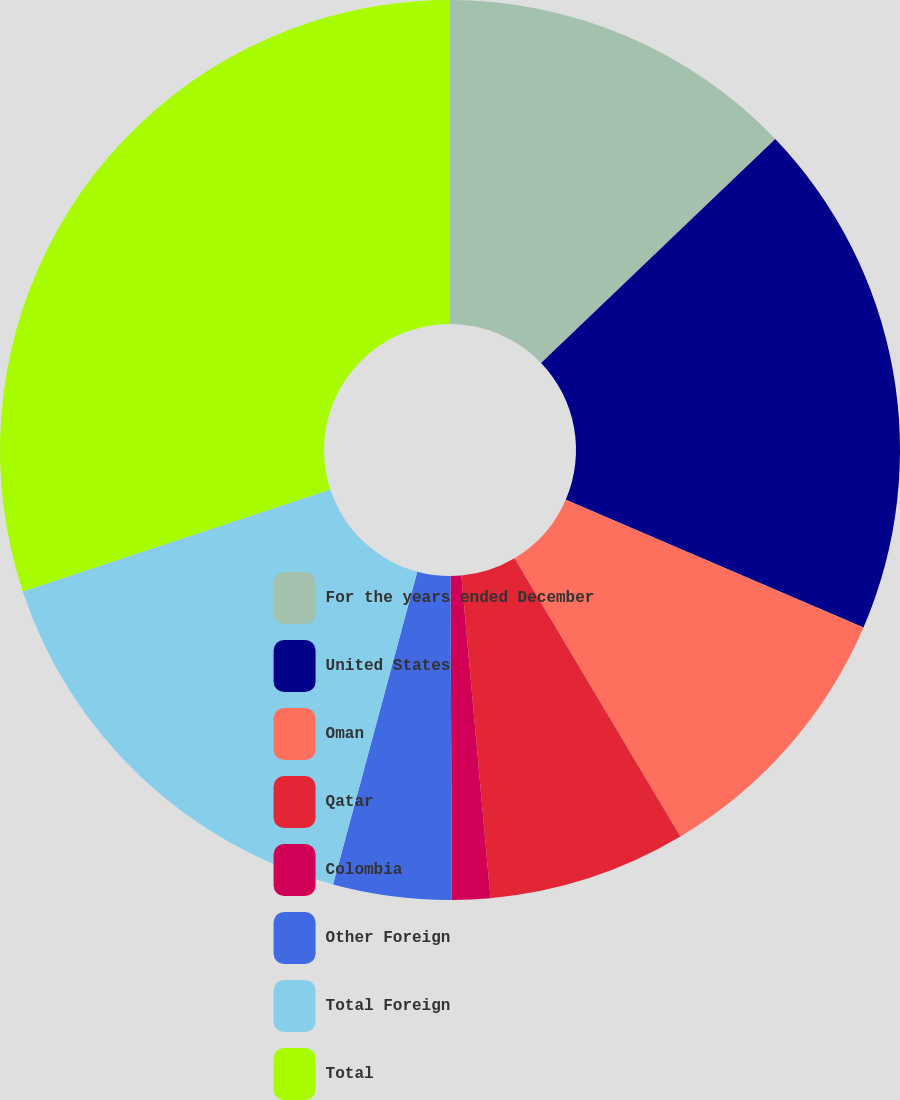<chart> <loc_0><loc_0><loc_500><loc_500><pie_chart><fcel>For the years ended December<fcel>United States<fcel>Oman<fcel>Qatar<fcel>Colombia<fcel>Other Foreign<fcel>Total Foreign<fcel>Total<nl><fcel>12.86%<fcel>18.6%<fcel>9.99%<fcel>7.12%<fcel>1.37%<fcel>4.25%<fcel>15.73%<fcel>30.09%<nl></chart> 